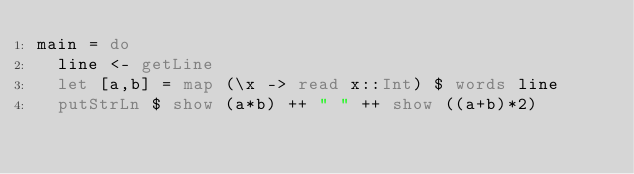Convert code to text. <code><loc_0><loc_0><loc_500><loc_500><_Haskell_>main = do
  line <- getLine
  let [a,b] = map (\x -> read x::Int) $ words line
  putStrLn $ show (a*b) ++ " " ++ show ((a+b)*2)</code> 